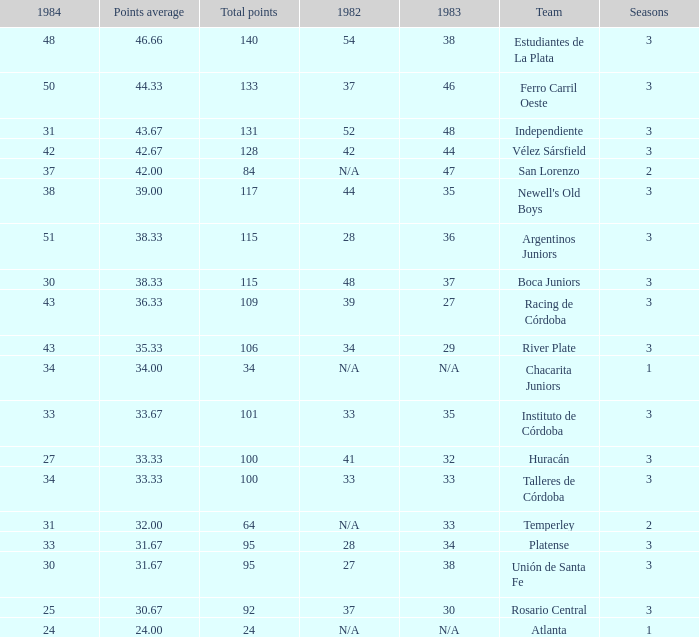What is the total for 1984 for the team with 100 points total and more than 3 seasons? None. 